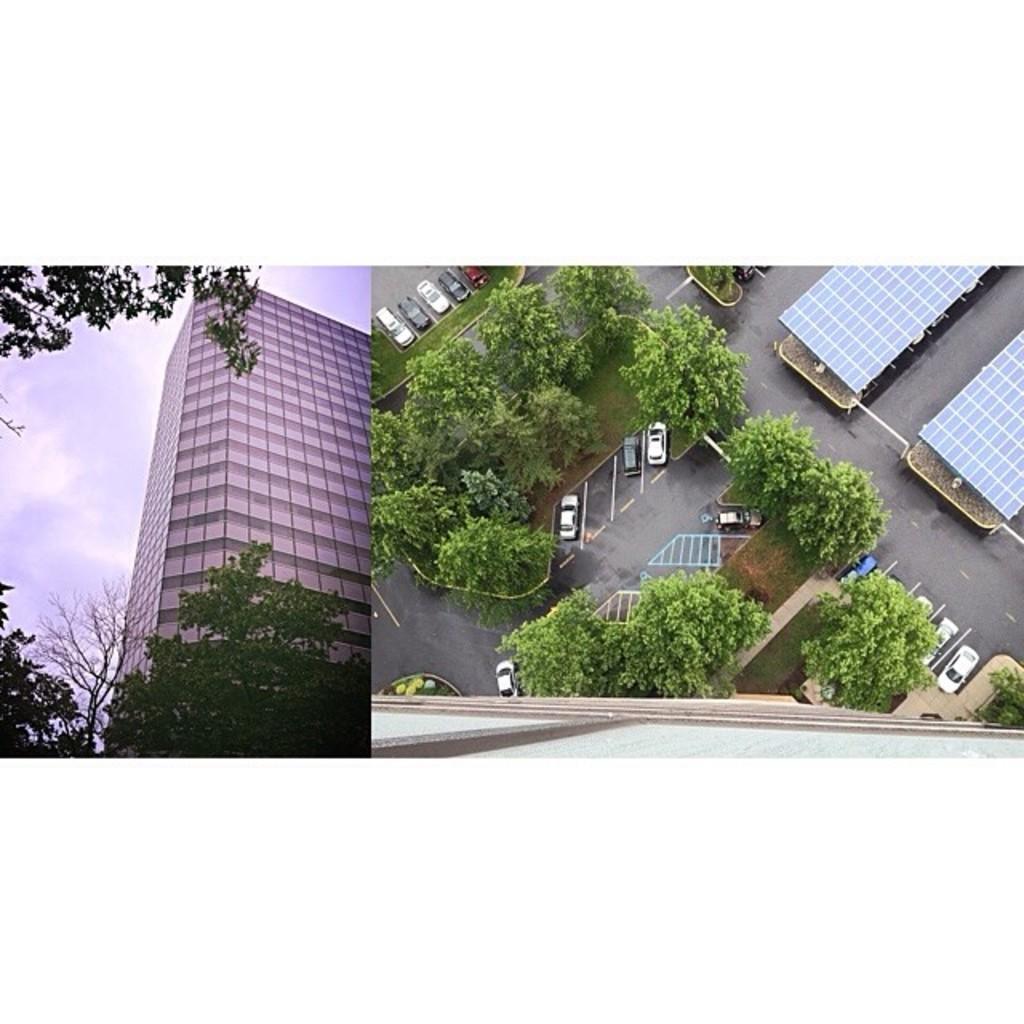Could you give a brief overview of what you see in this image? This image is a collage of 2 images. On the left side there is a building and there are trees and the sky is cloudy. On the right side of the image there are cars on the road and there are trees and there are tents. 